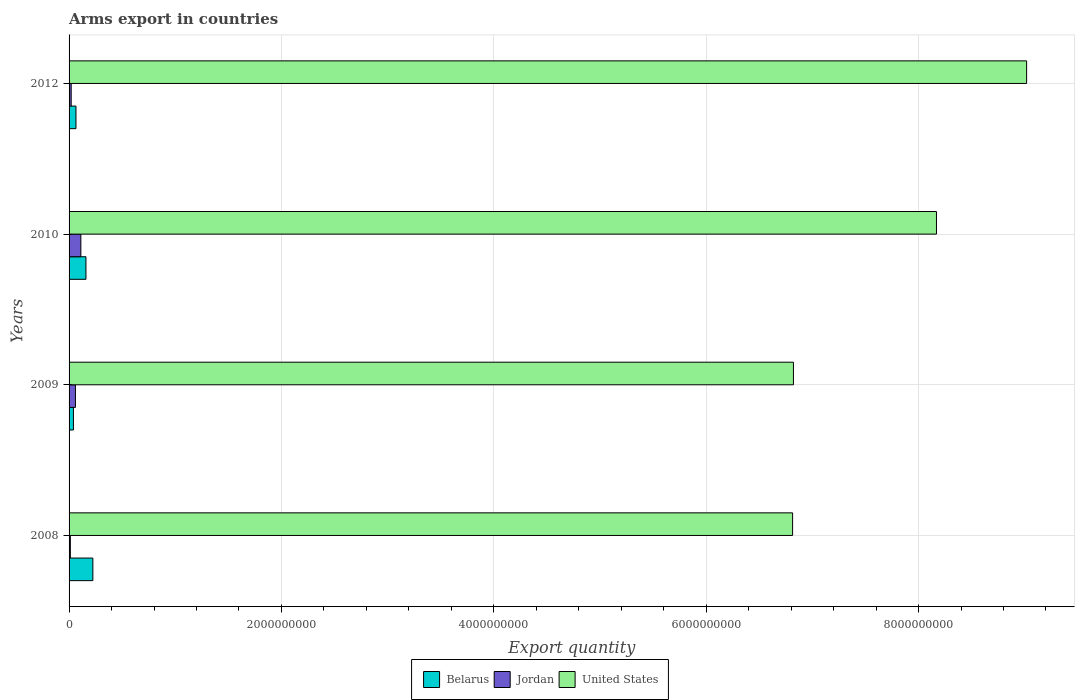How many different coloured bars are there?
Your answer should be very brief. 3. How many groups of bars are there?
Your answer should be compact. 4. How many bars are there on the 4th tick from the top?
Provide a short and direct response. 3. What is the total arms export in Jordan in 2010?
Make the answer very short. 1.11e+08. Across all years, what is the maximum total arms export in Jordan?
Your response must be concise. 1.11e+08. In which year was the total arms export in Jordan maximum?
Provide a short and direct response. 2010. What is the total total arms export in Jordan in the graph?
Your answer should be very brief. 2.03e+08. What is the difference between the total arms export in Jordan in 2010 and that in 2012?
Your answer should be very brief. 9.10e+07. What is the difference between the total arms export in Belarus in 2009 and the total arms export in Jordan in 2012?
Your response must be concise. 2.10e+07. What is the average total arms export in United States per year?
Offer a very short reply. 7.71e+09. In the year 2012, what is the difference between the total arms export in Jordan and total arms export in United States?
Your answer should be compact. -9.00e+09. In how many years, is the total arms export in United States greater than 4800000000 ?
Give a very brief answer. 4. What is the difference between the highest and the second highest total arms export in Jordan?
Offer a terse response. 5.10e+07. What is the difference between the highest and the lowest total arms export in Belarus?
Give a very brief answer. 1.83e+08. Is the sum of the total arms export in United States in 2008 and 2010 greater than the maximum total arms export in Belarus across all years?
Offer a terse response. Yes. What does the 3rd bar from the top in 2012 represents?
Your response must be concise. Belarus. What does the 1st bar from the bottom in 2008 represents?
Ensure brevity in your answer.  Belarus. How many bars are there?
Keep it short and to the point. 12. Where does the legend appear in the graph?
Offer a very short reply. Bottom center. How many legend labels are there?
Your answer should be very brief. 3. What is the title of the graph?
Provide a short and direct response. Arms export in countries. Does "French Polynesia" appear as one of the legend labels in the graph?
Ensure brevity in your answer.  No. What is the label or title of the X-axis?
Offer a terse response. Export quantity. What is the label or title of the Y-axis?
Make the answer very short. Years. What is the Export quantity in Belarus in 2008?
Keep it short and to the point. 2.24e+08. What is the Export quantity in United States in 2008?
Offer a very short reply. 6.81e+09. What is the Export quantity of Belarus in 2009?
Offer a terse response. 4.10e+07. What is the Export quantity in Jordan in 2009?
Provide a succinct answer. 6.00e+07. What is the Export quantity of United States in 2009?
Offer a very short reply. 6.82e+09. What is the Export quantity in Belarus in 2010?
Offer a very short reply. 1.59e+08. What is the Export quantity in Jordan in 2010?
Give a very brief answer. 1.11e+08. What is the Export quantity of United States in 2010?
Keep it short and to the point. 8.17e+09. What is the Export quantity of Belarus in 2012?
Offer a terse response. 6.50e+07. What is the Export quantity in United States in 2012?
Your answer should be compact. 9.02e+09. Across all years, what is the maximum Export quantity in Belarus?
Offer a very short reply. 2.24e+08. Across all years, what is the maximum Export quantity in Jordan?
Give a very brief answer. 1.11e+08. Across all years, what is the maximum Export quantity of United States?
Offer a very short reply. 9.02e+09. Across all years, what is the minimum Export quantity of Belarus?
Your response must be concise. 4.10e+07. Across all years, what is the minimum Export quantity of Jordan?
Offer a very short reply. 1.20e+07. Across all years, what is the minimum Export quantity in United States?
Provide a succinct answer. 6.81e+09. What is the total Export quantity in Belarus in the graph?
Keep it short and to the point. 4.89e+08. What is the total Export quantity of Jordan in the graph?
Provide a short and direct response. 2.03e+08. What is the total Export quantity in United States in the graph?
Your answer should be very brief. 3.08e+1. What is the difference between the Export quantity of Belarus in 2008 and that in 2009?
Your response must be concise. 1.83e+08. What is the difference between the Export quantity of Jordan in 2008 and that in 2009?
Your response must be concise. -4.80e+07. What is the difference between the Export quantity in United States in 2008 and that in 2009?
Provide a short and direct response. -8.00e+06. What is the difference between the Export quantity of Belarus in 2008 and that in 2010?
Provide a succinct answer. 6.50e+07. What is the difference between the Export quantity in Jordan in 2008 and that in 2010?
Provide a succinct answer. -9.90e+07. What is the difference between the Export quantity in United States in 2008 and that in 2010?
Give a very brief answer. -1.36e+09. What is the difference between the Export quantity of Belarus in 2008 and that in 2012?
Keep it short and to the point. 1.59e+08. What is the difference between the Export quantity of Jordan in 2008 and that in 2012?
Your answer should be compact. -8.00e+06. What is the difference between the Export quantity of United States in 2008 and that in 2012?
Provide a short and direct response. -2.20e+09. What is the difference between the Export quantity in Belarus in 2009 and that in 2010?
Ensure brevity in your answer.  -1.18e+08. What is the difference between the Export quantity of Jordan in 2009 and that in 2010?
Make the answer very short. -5.10e+07. What is the difference between the Export quantity of United States in 2009 and that in 2010?
Offer a terse response. -1.35e+09. What is the difference between the Export quantity of Belarus in 2009 and that in 2012?
Your response must be concise. -2.40e+07. What is the difference between the Export quantity in Jordan in 2009 and that in 2012?
Offer a terse response. 4.00e+07. What is the difference between the Export quantity of United States in 2009 and that in 2012?
Ensure brevity in your answer.  -2.20e+09. What is the difference between the Export quantity in Belarus in 2010 and that in 2012?
Your answer should be very brief. 9.40e+07. What is the difference between the Export quantity in Jordan in 2010 and that in 2012?
Keep it short and to the point. 9.10e+07. What is the difference between the Export quantity of United States in 2010 and that in 2012?
Offer a very short reply. -8.49e+08. What is the difference between the Export quantity in Belarus in 2008 and the Export quantity in Jordan in 2009?
Your answer should be compact. 1.64e+08. What is the difference between the Export quantity in Belarus in 2008 and the Export quantity in United States in 2009?
Provide a short and direct response. -6.60e+09. What is the difference between the Export quantity in Jordan in 2008 and the Export quantity in United States in 2009?
Offer a terse response. -6.81e+09. What is the difference between the Export quantity of Belarus in 2008 and the Export quantity of Jordan in 2010?
Keep it short and to the point. 1.13e+08. What is the difference between the Export quantity in Belarus in 2008 and the Export quantity in United States in 2010?
Provide a short and direct response. -7.94e+09. What is the difference between the Export quantity of Jordan in 2008 and the Export quantity of United States in 2010?
Keep it short and to the point. -8.16e+09. What is the difference between the Export quantity of Belarus in 2008 and the Export quantity of Jordan in 2012?
Ensure brevity in your answer.  2.04e+08. What is the difference between the Export quantity in Belarus in 2008 and the Export quantity in United States in 2012?
Keep it short and to the point. -8.79e+09. What is the difference between the Export quantity of Jordan in 2008 and the Export quantity of United States in 2012?
Your answer should be very brief. -9.01e+09. What is the difference between the Export quantity in Belarus in 2009 and the Export quantity in Jordan in 2010?
Offer a terse response. -7.00e+07. What is the difference between the Export quantity in Belarus in 2009 and the Export quantity in United States in 2010?
Provide a short and direct response. -8.13e+09. What is the difference between the Export quantity in Jordan in 2009 and the Export quantity in United States in 2010?
Provide a short and direct response. -8.11e+09. What is the difference between the Export quantity of Belarus in 2009 and the Export quantity of Jordan in 2012?
Offer a very short reply. 2.10e+07. What is the difference between the Export quantity in Belarus in 2009 and the Export quantity in United States in 2012?
Your answer should be very brief. -8.98e+09. What is the difference between the Export quantity in Jordan in 2009 and the Export quantity in United States in 2012?
Ensure brevity in your answer.  -8.96e+09. What is the difference between the Export quantity in Belarus in 2010 and the Export quantity in Jordan in 2012?
Your answer should be compact. 1.39e+08. What is the difference between the Export quantity of Belarus in 2010 and the Export quantity of United States in 2012?
Give a very brief answer. -8.86e+09. What is the difference between the Export quantity in Jordan in 2010 and the Export quantity in United States in 2012?
Ensure brevity in your answer.  -8.91e+09. What is the average Export quantity of Belarus per year?
Give a very brief answer. 1.22e+08. What is the average Export quantity in Jordan per year?
Ensure brevity in your answer.  5.08e+07. What is the average Export quantity in United States per year?
Your answer should be compact. 7.71e+09. In the year 2008, what is the difference between the Export quantity of Belarus and Export quantity of Jordan?
Provide a succinct answer. 2.12e+08. In the year 2008, what is the difference between the Export quantity in Belarus and Export quantity in United States?
Give a very brief answer. -6.59e+09. In the year 2008, what is the difference between the Export quantity in Jordan and Export quantity in United States?
Provide a short and direct response. -6.80e+09. In the year 2009, what is the difference between the Export quantity in Belarus and Export quantity in Jordan?
Your answer should be compact. -1.90e+07. In the year 2009, what is the difference between the Export quantity in Belarus and Export quantity in United States?
Keep it short and to the point. -6.78e+09. In the year 2009, what is the difference between the Export quantity in Jordan and Export quantity in United States?
Provide a short and direct response. -6.76e+09. In the year 2010, what is the difference between the Export quantity of Belarus and Export quantity of Jordan?
Your response must be concise. 4.80e+07. In the year 2010, what is the difference between the Export quantity of Belarus and Export quantity of United States?
Make the answer very short. -8.01e+09. In the year 2010, what is the difference between the Export quantity of Jordan and Export quantity of United States?
Your answer should be compact. -8.06e+09. In the year 2012, what is the difference between the Export quantity of Belarus and Export quantity of Jordan?
Offer a very short reply. 4.50e+07. In the year 2012, what is the difference between the Export quantity in Belarus and Export quantity in United States?
Ensure brevity in your answer.  -8.95e+09. In the year 2012, what is the difference between the Export quantity in Jordan and Export quantity in United States?
Your response must be concise. -9.00e+09. What is the ratio of the Export quantity of Belarus in 2008 to that in 2009?
Your answer should be compact. 5.46. What is the ratio of the Export quantity of Belarus in 2008 to that in 2010?
Ensure brevity in your answer.  1.41. What is the ratio of the Export quantity in Jordan in 2008 to that in 2010?
Your answer should be very brief. 0.11. What is the ratio of the Export quantity of United States in 2008 to that in 2010?
Your answer should be very brief. 0.83. What is the ratio of the Export quantity of Belarus in 2008 to that in 2012?
Provide a short and direct response. 3.45. What is the ratio of the Export quantity of Jordan in 2008 to that in 2012?
Give a very brief answer. 0.6. What is the ratio of the Export quantity of United States in 2008 to that in 2012?
Offer a very short reply. 0.76. What is the ratio of the Export quantity of Belarus in 2009 to that in 2010?
Your answer should be compact. 0.26. What is the ratio of the Export quantity of Jordan in 2009 to that in 2010?
Your answer should be compact. 0.54. What is the ratio of the Export quantity in United States in 2009 to that in 2010?
Your answer should be compact. 0.84. What is the ratio of the Export quantity of Belarus in 2009 to that in 2012?
Offer a very short reply. 0.63. What is the ratio of the Export quantity in United States in 2009 to that in 2012?
Provide a succinct answer. 0.76. What is the ratio of the Export quantity of Belarus in 2010 to that in 2012?
Your response must be concise. 2.45. What is the ratio of the Export quantity of Jordan in 2010 to that in 2012?
Give a very brief answer. 5.55. What is the ratio of the Export quantity in United States in 2010 to that in 2012?
Give a very brief answer. 0.91. What is the difference between the highest and the second highest Export quantity of Belarus?
Provide a succinct answer. 6.50e+07. What is the difference between the highest and the second highest Export quantity in Jordan?
Offer a very short reply. 5.10e+07. What is the difference between the highest and the second highest Export quantity in United States?
Give a very brief answer. 8.49e+08. What is the difference between the highest and the lowest Export quantity of Belarus?
Keep it short and to the point. 1.83e+08. What is the difference between the highest and the lowest Export quantity of Jordan?
Ensure brevity in your answer.  9.90e+07. What is the difference between the highest and the lowest Export quantity of United States?
Offer a very short reply. 2.20e+09. 